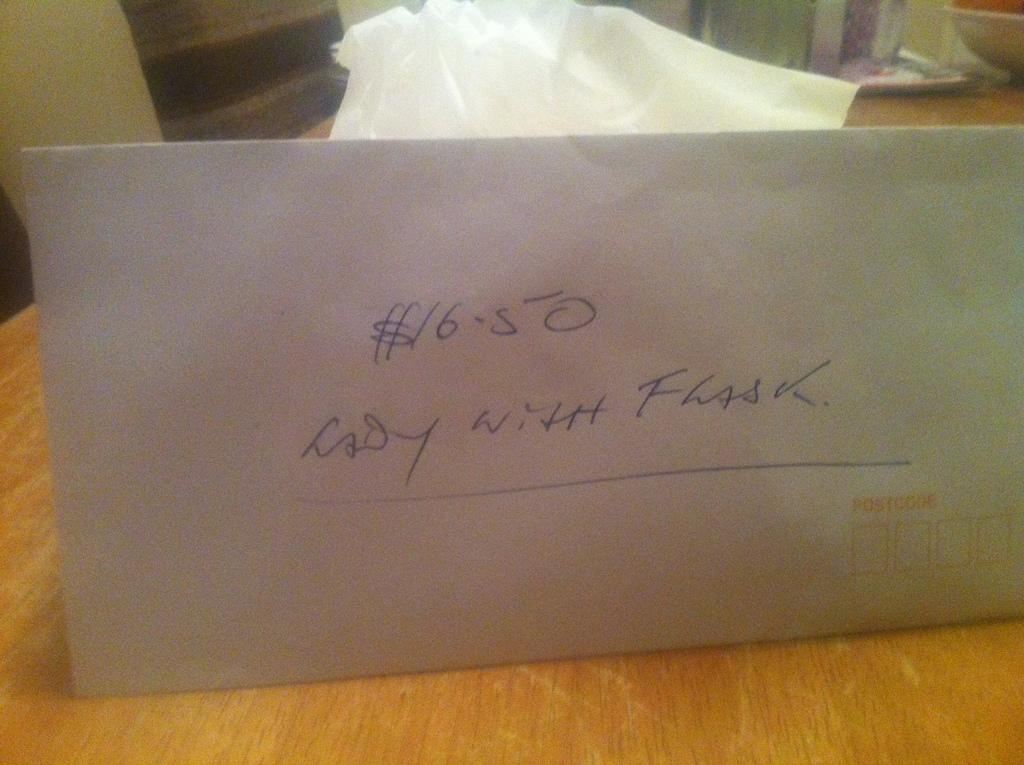<image>
Describe the image concisely. An envelope containing $16.50 sits propped up on a wooden table. 